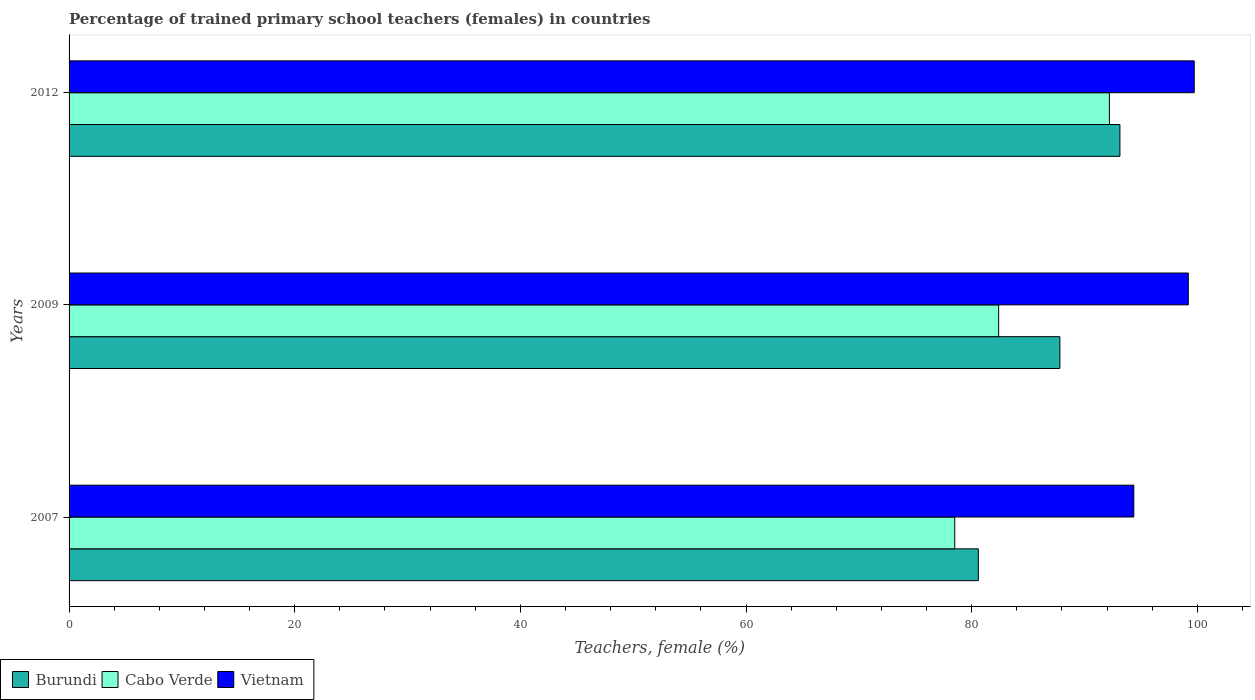Are the number of bars per tick equal to the number of legend labels?
Ensure brevity in your answer.  Yes. How many bars are there on the 2nd tick from the top?
Your response must be concise. 3. How many bars are there on the 3rd tick from the bottom?
Ensure brevity in your answer.  3. What is the percentage of trained primary school teachers (females) in Burundi in 2012?
Offer a very short reply. 93.14. Across all years, what is the maximum percentage of trained primary school teachers (females) in Burundi?
Keep it short and to the point. 93.14. Across all years, what is the minimum percentage of trained primary school teachers (females) in Cabo Verde?
Ensure brevity in your answer.  78.5. In which year was the percentage of trained primary school teachers (females) in Cabo Verde minimum?
Ensure brevity in your answer.  2007. What is the total percentage of trained primary school teachers (females) in Burundi in the graph?
Make the answer very short. 261.56. What is the difference between the percentage of trained primary school teachers (females) in Cabo Verde in 2009 and that in 2012?
Provide a succinct answer. -9.82. What is the difference between the percentage of trained primary school teachers (females) in Cabo Verde in 2009 and the percentage of trained primary school teachers (females) in Vietnam in 2012?
Keep it short and to the point. -17.34. What is the average percentage of trained primary school teachers (females) in Cabo Verde per year?
Ensure brevity in your answer.  84.37. In the year 2012, what is the difference between the percentage of trained primary school teachers (females) in Burundi and percentage of trained primary school teachers (females) in Cabo Verde?
Your response must be concise. 0.93. What is the ratio of the percentage of trained primary school teachers (females) in Vietnam in 2007 to that in 2009?
Give a very brief answer. 0.95. Is the difference between the percentage of trained primary school teachers (females) in Burundi in 2007 and 2009 greater than the difference between the percentage of trained primary school teachers (females) in Cabo Verde in 2007 and 2009?
Ensure brevity in your answer.  No. What is the difference between the highest and the second highest percentage of trained primary school teachers (females) in Cabo Verde?
Provide a short and direct response. 9.82. What is the difference between the highest and the lowest percentage of trained primary school teachers (females) in Cabo Verde?
Give a very brief answer. 13.71. In how many years, is the percentage of trained primary school teachers (females) in Burundi greater than the average percentage of trained primary school teachers (females) in Burundi taken over all years?
Offer a very short reply. 2. Is the sum of the percentage of trained primary school teachers (females) in Cabo Verde in 2007 and 2012 greater than the maximum percentage of trained primary school teachers (females) in Burundi across all years?
Provide a succinct answer. Yes. What does the 3rd bar from the top in 2012 represents?
Offer a very short reply. Burundi. What does the 2nd bar from the bottom in 2007 represents?
Your answer should be very brief. Cabo Verde. How many bars are there?
Provide a succinct answer. 9. Are all the bars in the graph horizontal?
Your answer should be compact. Yes. How many years are there in the graph?
Offer a terse response. 3. Are the values on the major ticks of X-axis written in scientific E-notation?
Ensure brevity in your answer.  No. Does the graph contain grids?
Your answer should be very brief. No. How many legend labels are there?
Keep it short and to the point. 3. What is the title of the graph?
Give a very brief answer. Percentage of trained primary school teachers (females) in countries. What is the label or title of the X-axis?
Provide a succinct answer. Teachers, female (%). What is the label or title of the Y-axis?
Provide a short and direct response. Years. What is the Teachers, female (%) in Burundi in 2007?
Make the answer very short. 80.59. What is the Teachers, female (%) of Cabo Verde in 2007?
Your response must be concise. 78.5. What is the Teachers, female (%) in Vietnam in 2007?
Keep it short and to the point. 94.37. What is the Teachers, female (%) in Burundi in 2009?
Your answer should be compact. 87.82. What is the Teachers, female (%) in Cabo Verde in 2009?
Keep it short and to the point. 82.39. What is the Teachers, female (%) of Vietnam in 2009?
Provide a short and direct response. 99.21. What is the Teachers, female (%) in Burundi in 2012?
Give a very brief answer. 93.14. What is the Teachers, female (%) in Cabo Verde in 2012?
Provide a short and direct response. 92.21. What is the Teachers, female (%) of Vietnam in 2012?
Provide a succinct answer. 99.73. Across all years, what is the maximum Teachers, female (%) of Burundi?
Give a very brief answer. 93.14. Across all years, what is the maximum Teachers, female (%) in Cabo Verde?
Your answer should be compact. 92.21. Across all years, what is the maximum Teachers, female (%) of Vietnam?
Give a very brief answer. 99.73. Across all years, what is the minimum Teachers, female (%) in Burundi?
Give a very brief answer. 80.59. Across all years, what is the minimum Teachers, female (%) in Cabo Verde?
Your response must be concise. 78.5. Across all years, what is the minimum Teachers, female (%) in Vietnam?
Make the answer very short. 94.37. What is the total Teachers, female (%) in Burundi in the graph?
Provide a succinct answer. 261.56. What is the total Teachers, female (%) of Cabo Verde in the graph?
Keep it short and to the point. 253.11. What is the total Teachers, female (%) in Vietnam in the graph?
Your answer should be very brief. 293.31. What is the difference between the Teachers, female (%) of Burundi in 2007 and that in 2009?
Keep it short and to the point. -7.23. What is the difference between the Teachers, female (%) of Cabo Verde in 2007 and that in 2009?
Give a very brief answer. -3.89. What is the difference between the Teachers, female (%) of Vietnam in 2007 and that in 2009?
Your response must be concise. -4.83. What is the difference between the Teachers, female (%) of Burundi in 2007 and that in 2012?
Provide a succinct answer. -12.55. What is the difference between the Teachers, female (%) of Cabo Verde in 2007 and that in 2012?
Your answer should be compact. -13.71. What is the difference between the Teachers, female (%) in Vietnam in 2007 and that in 2012?
Make the answer very short. -5.36. What is the difference between the Teachers, female (%) in Burundi in 2009 and that in 2012?
Offer a very short reply. -5.32. What is the difference between the Teachers, female (%) in Cabo Verde in 2009 and that in 2012?
Offer a very short reply. -9.82. What is the difference between the Teachers, female (%) of Vietnam in 2009 and that in 2012?
Give a very brief answer. -0.53. What is the difference between the Teachers, female (%) of Burundi in 2007 and the Teachers, female (%) of Cabo Verde in 2009?
Your response must be concise. -1.8. What is the difference between the Teachers, female (%) in Burundi in 2007 and the Teachers, female (%) in Vietnam in 2009?
Make the answer very short. -18.61. What is the difference between the Teachers, female (%) in Cabo Verde in 2007 and the Teachers, female (%) in Vietnam in 2009?
Ensure brevity in your answer.  -20.7. What is the difference between the Teachers, female (%) in Burundi in 2007 and the Teachers, female (%) in Cabo Verde in 2012?
Your answer should be compact. -11.62. What is the difference between the Teachers, female (%) in Burundi in 2007 and the Teachers, female (%) in Vietnam in 2012?
Provide a succinct answer. -19.14. What is the difference between the Teachers, female (%) in Cabo Verde in 2007 and the Teachers, female (%) in Vietnam in 2012?
Offer a very short reply. -21.23. What is the difference between the Teachers, female (%) in Burundi in 2009 and the Teachers, female (%) in Cabo Verde in 2012?
Your answer should be compact. -4.39. What is the difference between the Teachers, female (%) in Burundi in 2009 and the Teachers, female (%) in Vietnam in 2012?
Your answer should be very brief. -11.91. What is the difference between the Teachers, female (%) in Cabo Verde in 2009 and the Teachers, female (%) in Vietnam in 2012?
Provide a short and direct response. -17.34. What is the average Teachers, female (%) in Burundi per year?
Keep it short and to the point. 87.19. What is the average Teachers, female (%) in Cabo Verde per year?
Offer a very short reply. 84.37. What is the average Teachers, female (%) of Vietnam per year?
Provide a short and direct response. 97.77. In the year 2007, what is the difference between the Teachers, female (%) of Burundi and Teachers, female (%) of Cabo Verde?
Your answer should be very brief. 2.09. In the year 2007, what is the difference between the Teachers, female (%) in Burundi and Teachers, female (%) in Vietnam?
Offer a terse response. -13.78. In the year 2007, what is the difference between the Teachers, female (%) of Cabo Verde and Teachers, female (%) of Vietnam?
Keep it short and to the point. -15.87. In the year 2009, what is the difference between the Teachers, female (%) of Burundi and Teachers, female (%) of Cabo Verde?
Offer a terse response. 5.43. In the year 2009, what is the difference between the Teachers, female (%) in Burundi and Teachers, female (%) in Vietnam?
Provide a short and direct response. -11.38. In the year 2009, what is the difference between the Teachers, female (%) of Cabo Verde and Teachers, female (%) of Vietnam?
Give a very brief answer. -16.81. In the year 2012, what is the difference between the Teachers, female (%) of Burundi and Teachers, female (%) of Cabo Verde?
Offer a terse response. 0.93. In the year 2012, what is the difference between the Teachers, female (%) in Burundi and Teachers, female (%) in Vietnam?
Ensure brevity in your answer.  -6.59. In the year 2012, what is the difference between the Teachers, female (%) of Cabo Verde and Teachers, female (%) of Vietnam?
Offer a terse response. -7.52. What is the ratio of the Teachers, female (%) of Burundi in 2007 to that in 2009?
Ensure brevity in your answer.  0.92. What is the ratio of the Teachers, female (%) of Cabo Verde in 2007 to that in 2009?
Provide a short and direct response. 0.95. What is the ratio of the Teachers, female (%) of Vietnam in 2007 to that in 2009?
Keep it short and to the point. 0.95. What is the ratio of the Teachers, female (%) of Burundi in 2007 to that in 2012?
Your answer should be compact. 0.87. What is the ratio of the Teachers, female (%) of Cabo Verde in 2007 to that in 2012?
Offer a terse response. 0.85. What is the ratio of the Teachers, female (%) in Vietnam in 2007 to that in 2012?
Your answer should be compact. 0.95. What is the ratio of the Teachers, female (%) of Burundi in 2009 to that in 2012?
Offer a very short reply. 0.94. What is the ratio of the Teachers, female (%) in Cabo Verde in 2009 to that in 2012?
Your answer should be very brief. 0.89. What is the ratio of the Teachers, female (%) in Vietnam in 2009 to that in 2012?
Your response must be concise. 0.99. What is the difference between the highest and the second highest Teachers, female (%) in Burundi?
Your answer should be compact. 5.32. What is the difference between the highest and the second highest Teachers, female (%) of Cabo Verde?
Offer a terse response. 9.82. What is the difference between the highest and the second highest Teachers, female (%) of Vietnam?
Provide a short and direct response. 0.53. What is the difference between the highest and the lowest Teachers, female (%) in Burundi?
Offer a very short reply. 12.55. What is the difference between the highest and the lowest Teachers, female (%) of Cabo Verde?
Your response must be concise. 13.71. What is the difference between the highest and the lowest Teachers, female (%) in Vietnam?
Ensure brevity in your answer.  5.36. 